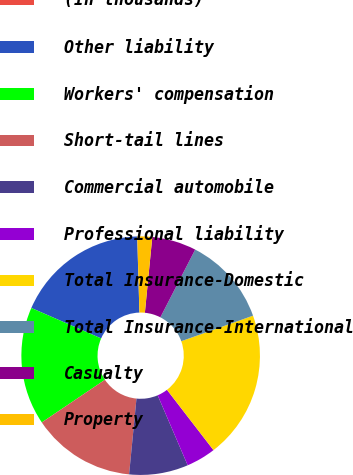Convert chart to OTSL. <chart><loc_0><loc_0><loc_500><loc_500><pie_chart><fcel>(In thousands)<fcel>Other liability<fcel>Workers' compensation<fcel>Short-tail lines<fcel>Commercial automobile<fcel>Professional liability<fcel>Total Insurance-Domestic<fcel>Total Insurance-International<fcel>Casualty<fcel>Property<nl><fcel>0.01%<fcel>17.99%<fcel>16.0%<fcel>14.0%<fcel>8.0%<fcel>4.0%<fcel>19.99%<fcel>12.0%<fcel>6.0%<fcel>2.01%<nl></chart> 